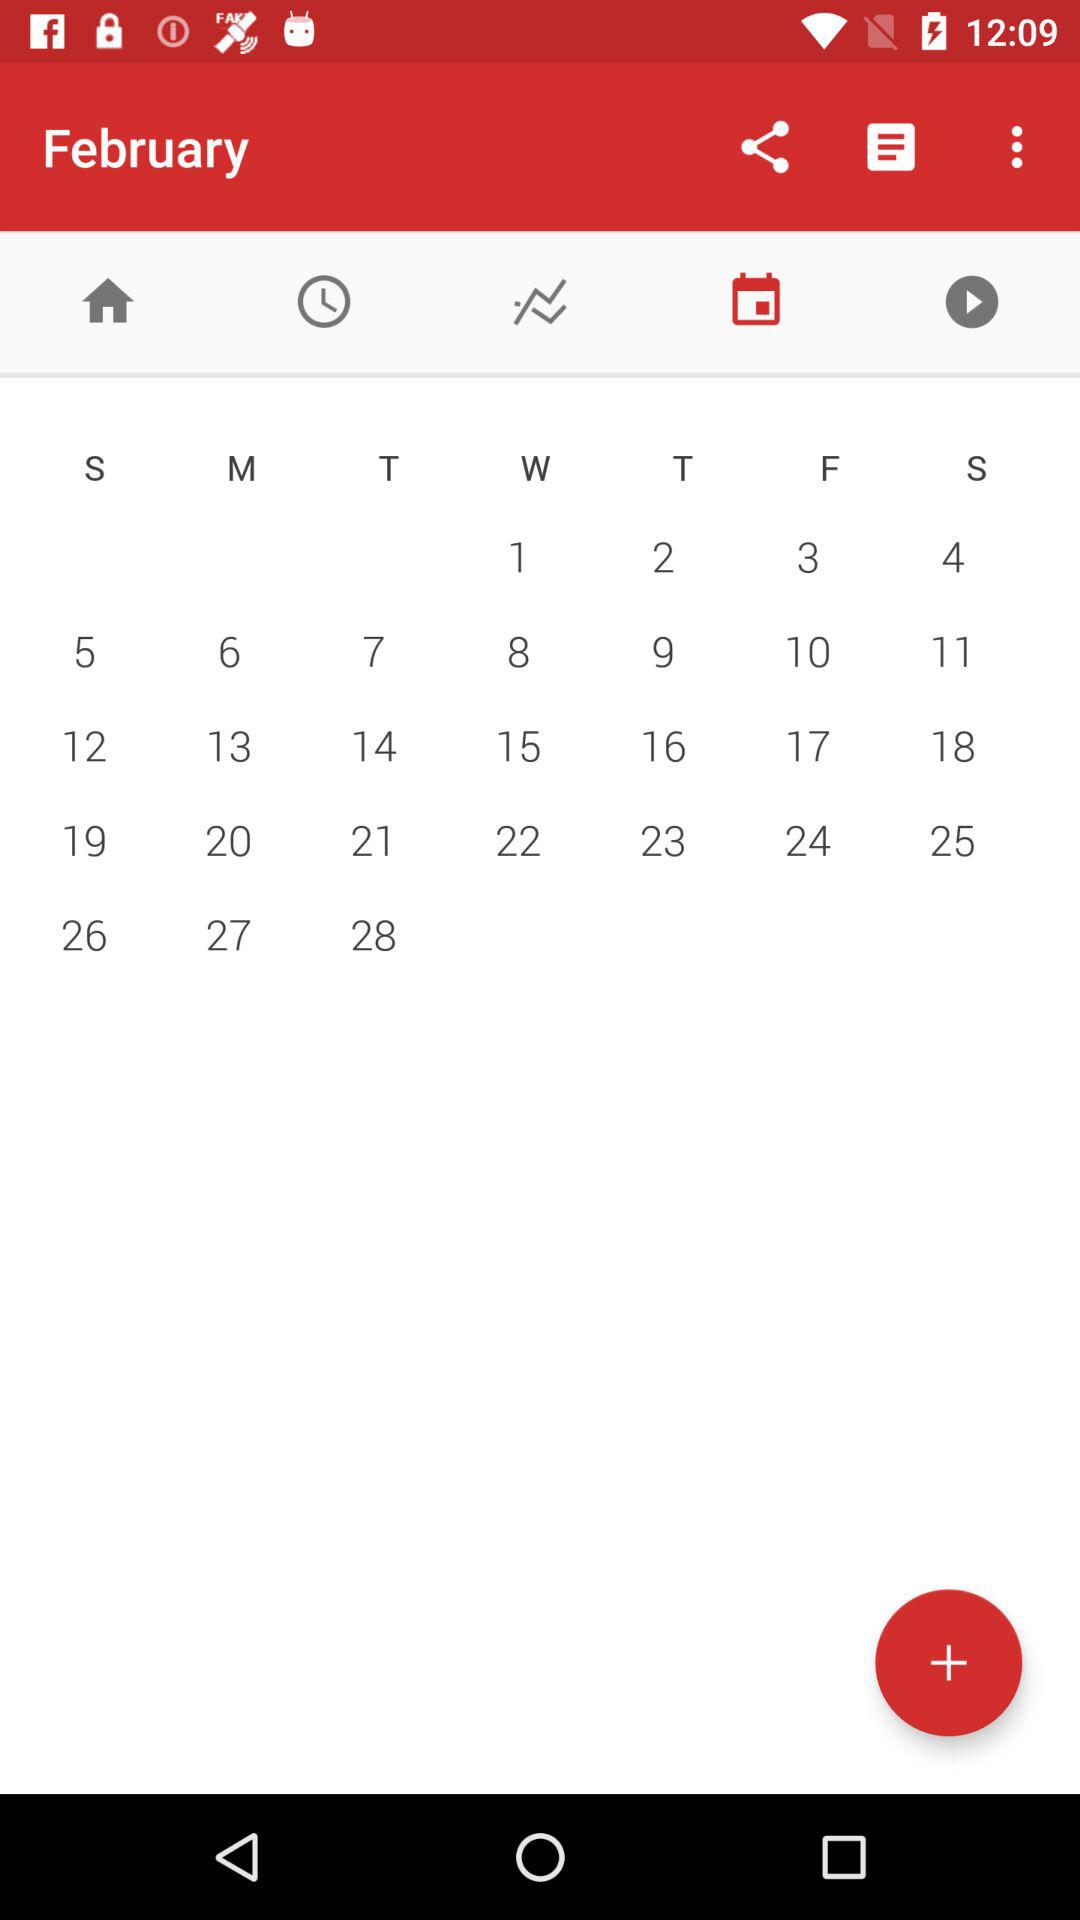What is the selected tab? The selected tab is "calendar". 